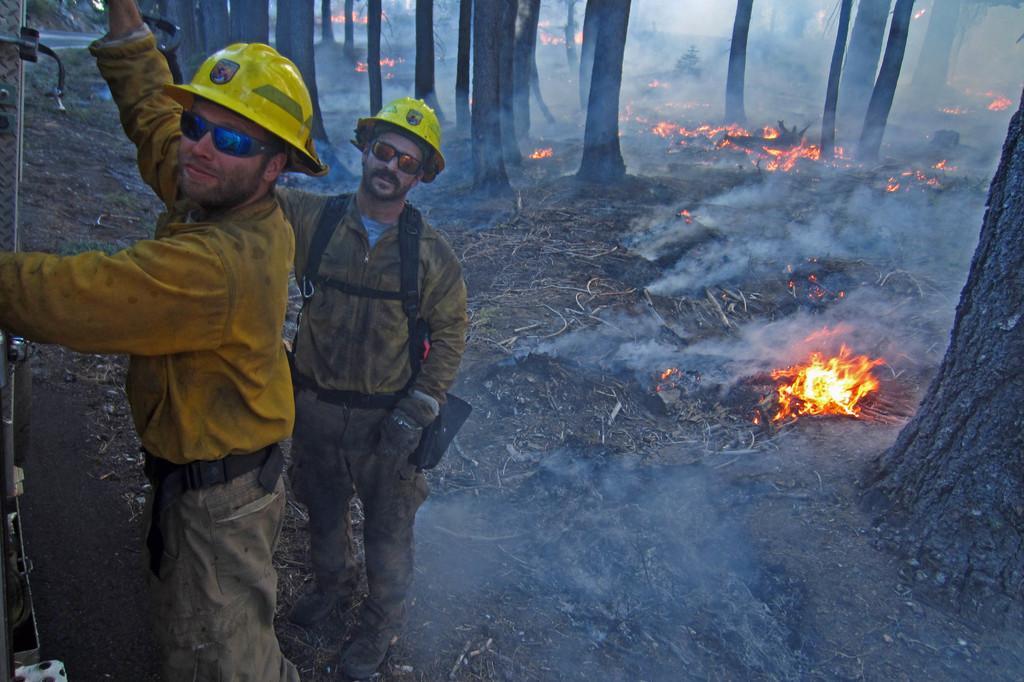In one or two sentences, can you explain what this image depicts? This picture shows couple of men standing they wore sunglasses on their face and caps on their heads and we see trees and fire on the ground. 